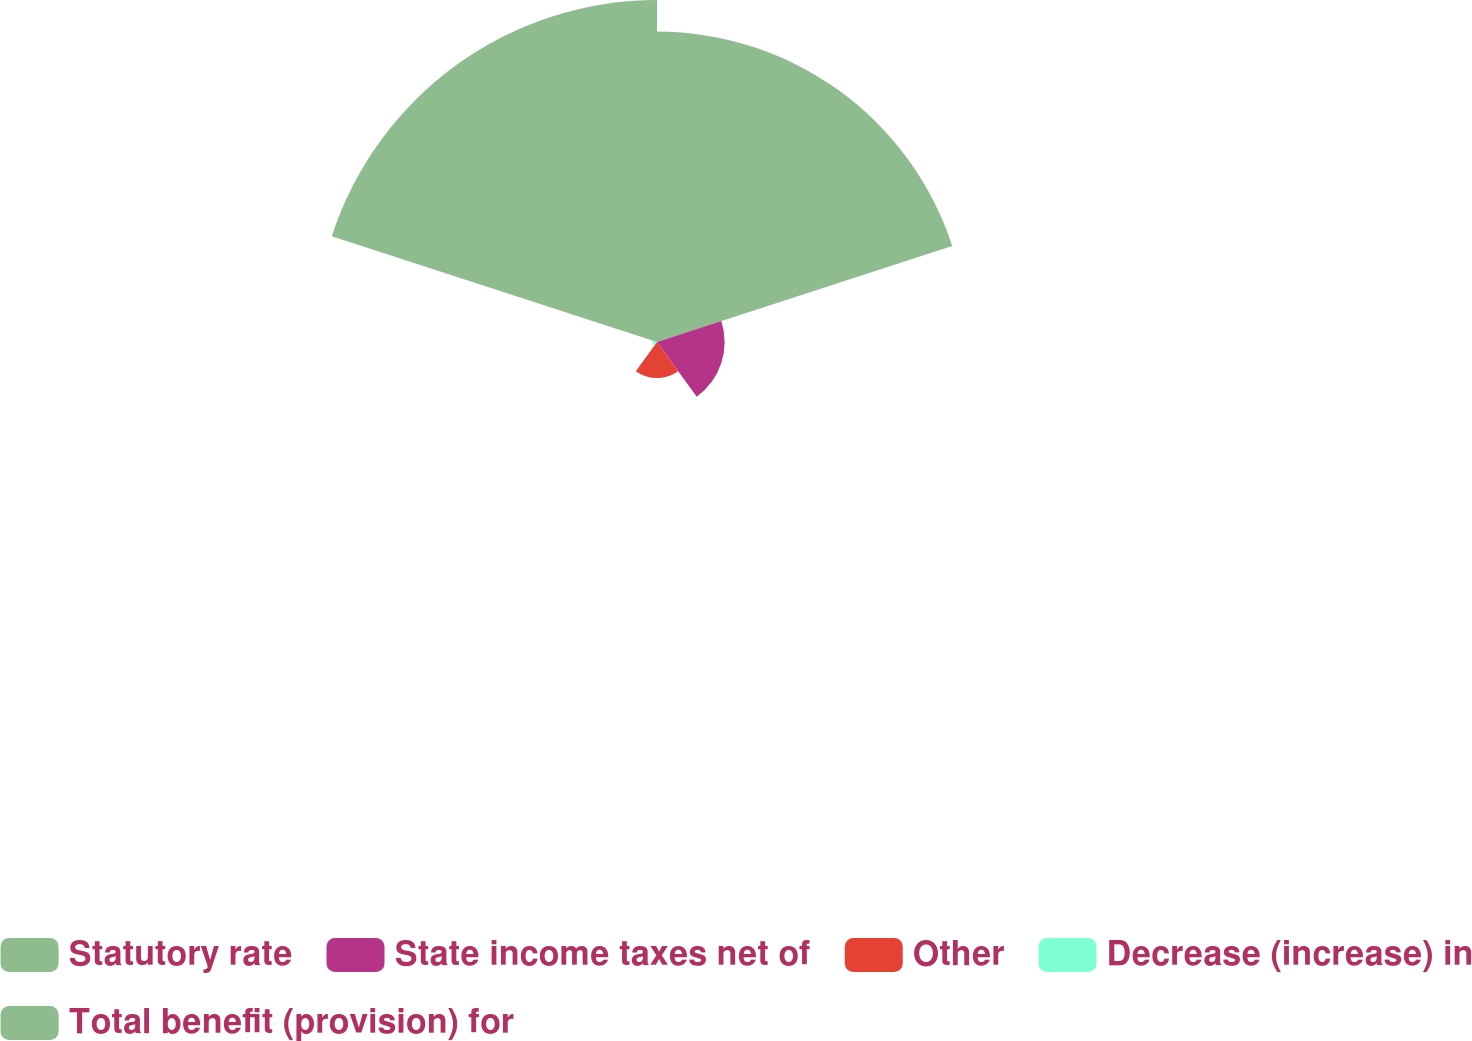Convert chart. <chart><loc_0><loc_0><loc_500><loc_500><pie_chart><fcel>Statutory rate<fcel>State income taxes net of<fcel>Other<fcel>Decrease (increase) in<fcel>Total benefit (provision) for<nl><fcel>40.82%<fcel>8.89%<fcel>4.74%<fcel>0.58%<fcel>44.97%<nl></chart> 